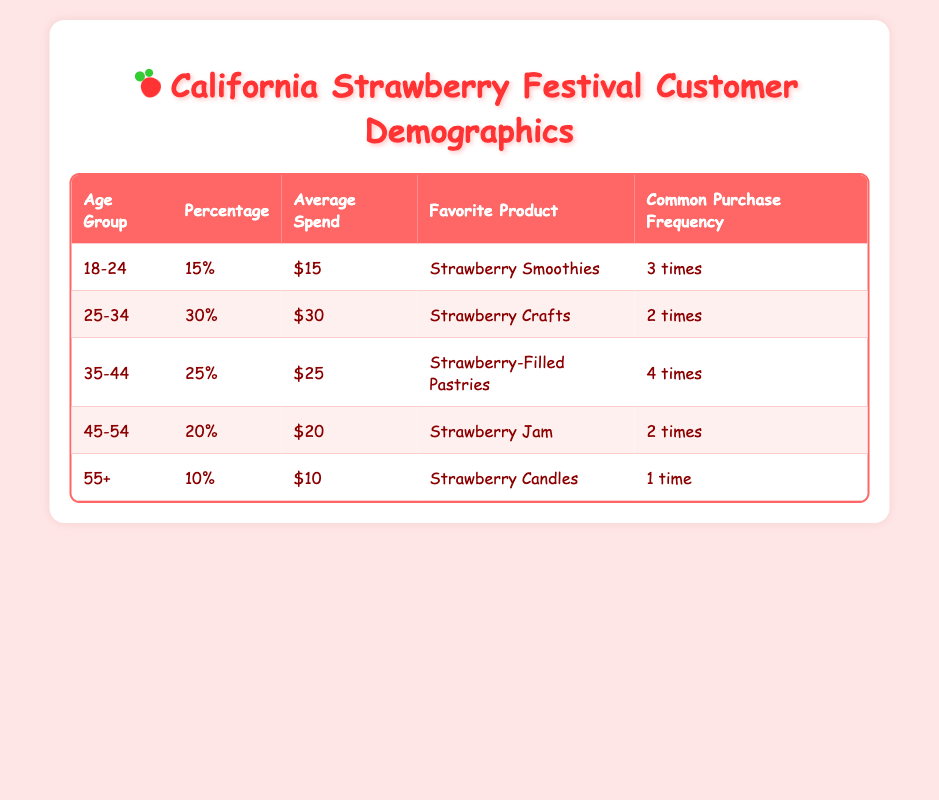What age group has the highest percentage of customers? The table shows that the age group with the highest percentage is 25-34, with a percentage of 30%.
Answer: 25-34 What is the average spend of the 35-44 age group? From the table, the average spend for the 35-44 age group is $25.
Answer: $25 What product do customers aged 55 and above favor? The table indicates that customers aged 55 and above favor Strawberry Candles.
Answer: Strawberry Candles Is the common purchase frequency for the 45-54 age group greater than for the 18-24 age group? The common purchase frequency for the 45-54 age group is 2 times, while for the 18-24 age group it is 3 times. Therefore, the 45-54 age group has a lower purchase frequency.
Answer: No What is the total percentage of customers in the 18-24 and 25-34 age groups combined? Adding the percentages from the two age groups: 15% (18-24) + 30% (25-34) = 45%.
Answer: 45% Which payment method is used by the majority of customers? The table states that 50% of customers use credit cards, which is more than any other payment method listed, including cash and mobile payment.
Answer: Credit Card How many different favorite products are listed for the different age groups? The table provides five different age groups, each with distinct favorite products: Strawberry Smoothies, Strawberry Crafts, Strawberry-Filled Pastries, Strawberry Jam, and Strawberry Candles. Thus, there are five different products listed.
Answer: Five If customers aged 35-44 purchase an average of 4 times, how does this compare to the 55+ age group? The 35-44 age group has a common purchase frequency of 4 times while the 55+ age group has a frequency of 1 time. This shows that customers aged 35-44 purchase more frequently than those aged 55+.
Answer: More What is the average spending of all age groups combined? To find the average spending across all age groups, add the average spends: 15 + 30 + 25 + 20 + 10 = 100. Since there are 5 age groups, divide 100 by 5, which equals 20.
Answer: $20 